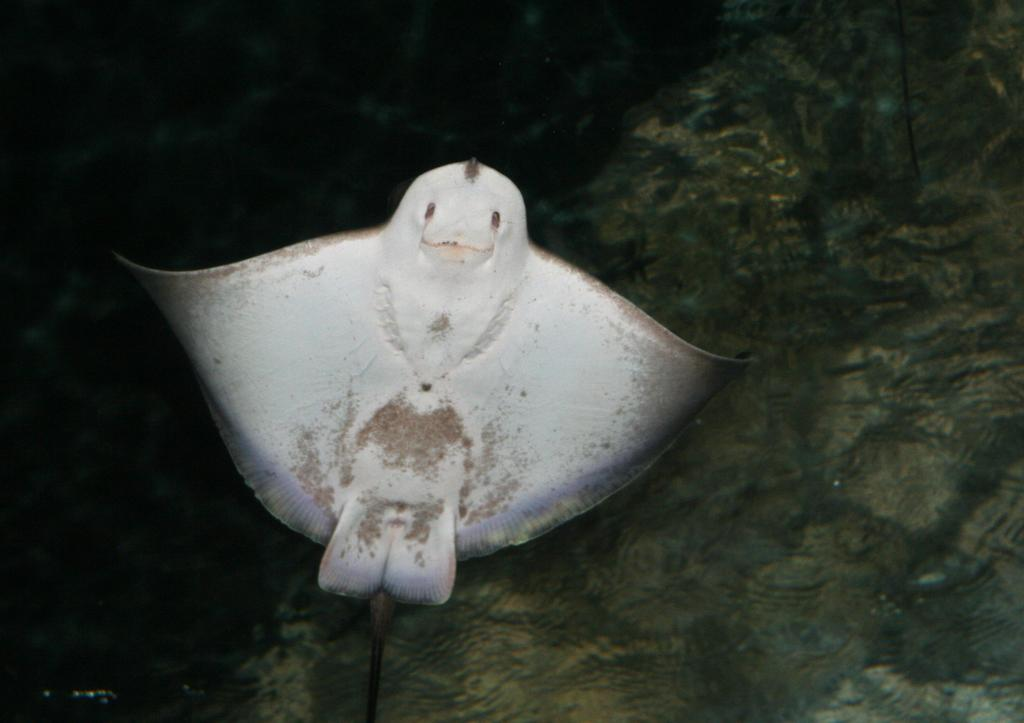What type of environment is depicted in the image? There is a water body in the image. What kind of creature can be seen in the water? There is a water animal in the image. What type of brass instrument is being played by the water animal in the image? There is no brass instrument or any indication of music being played in the image. 